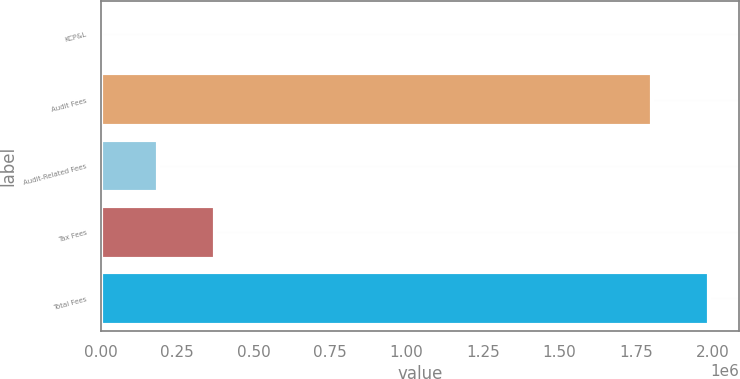Convert chart to OTSL. <chart><loc_0><loc_0><loc_500><loc_500><bar_chart><fcel>KCP&L<fcel>Audit Fees<fcel>Audit-Related Fees<fcel>Tax Fees<fcel>Total Fees<nl><fcel>2018<fcel>1.8014e+06<fcel>187732<fcel>373447<fcel>1.98711e+06<nl></chart> 